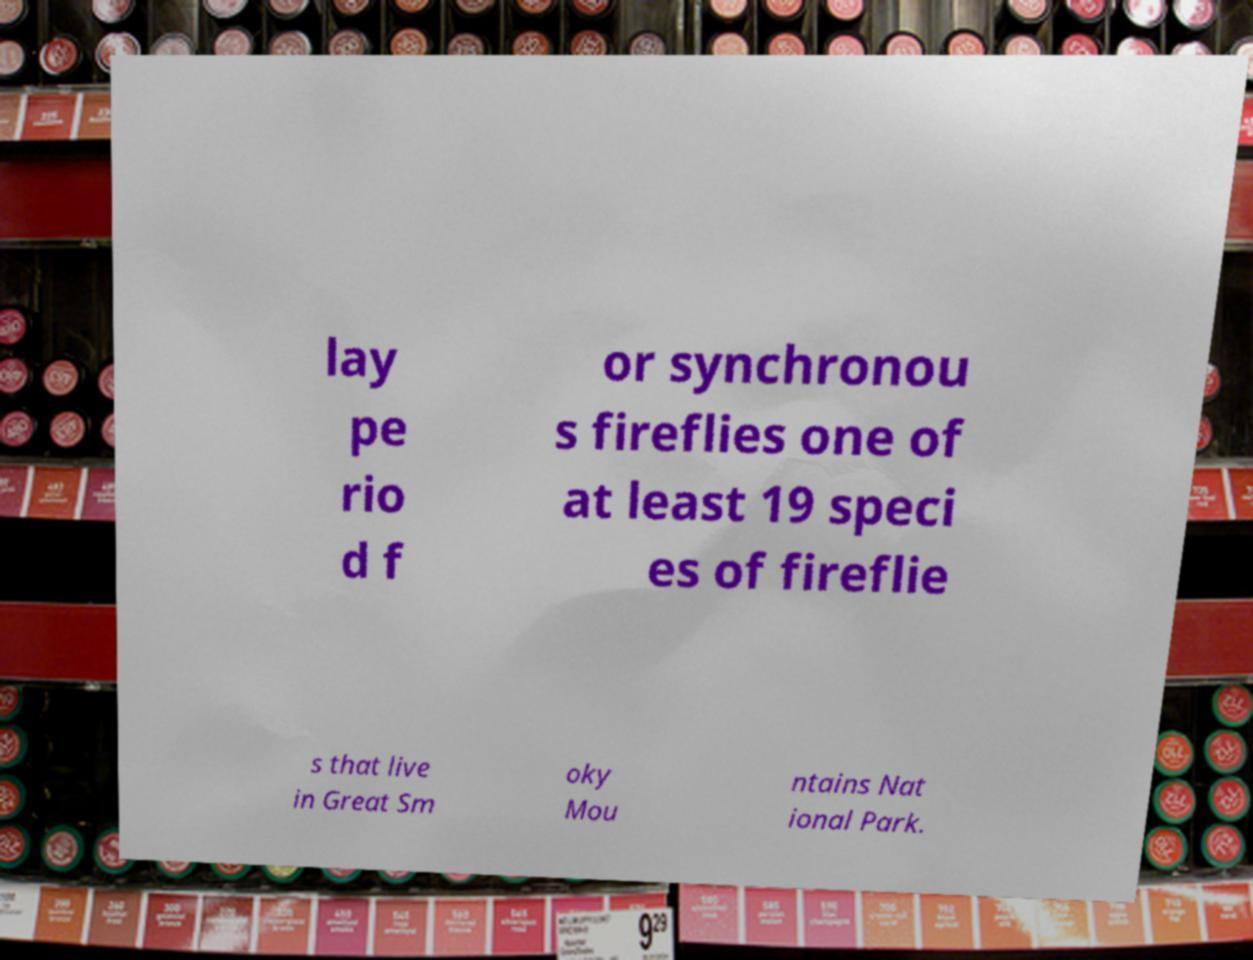For documentation purposes, I need the text within this image transcribed. Could you provide that? lay pe rio d f or synchronou s fireflies one of at least 19 speci es of fireflie s that live in Great Sm oky Mou ntains Nat ional Park. 